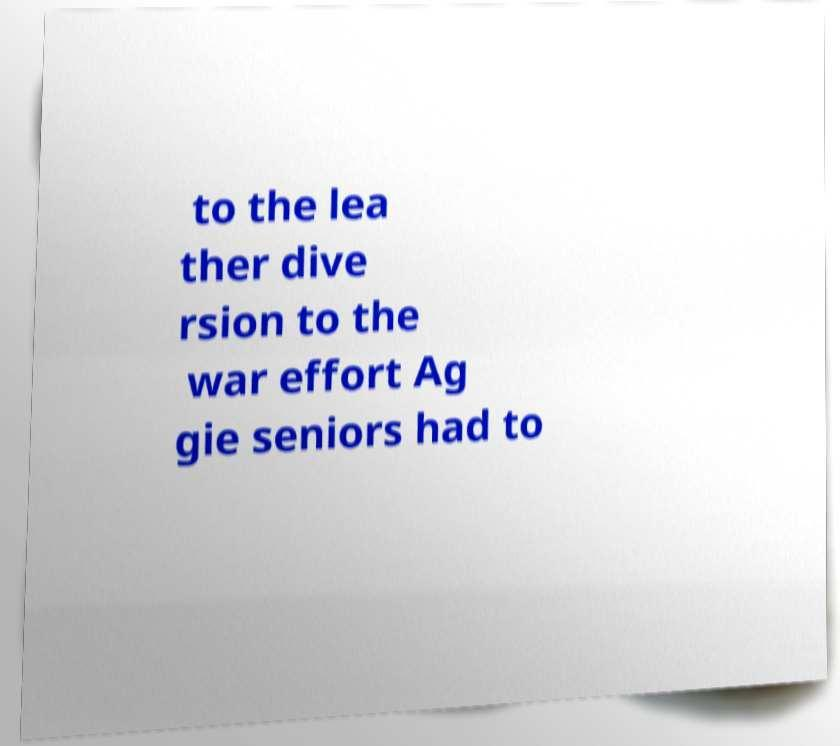Can you accurately transcribe the text from the provided image for me? to the lea ther dive rsion to the war effort Ag gie seniors had to 